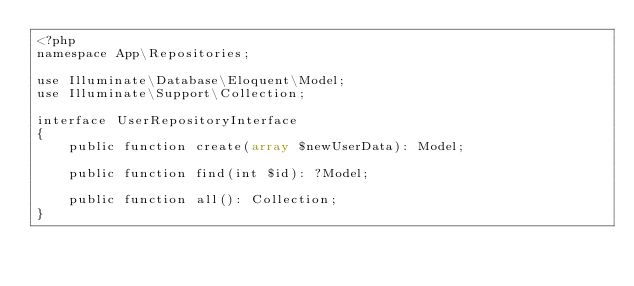<code> <loc_0><loc_0><loc_500><loc_500><_PHP_><?php
namespace App\Repositories;

use Illuminate\Database\Eloquent\Model;
use Illuminate\Support\Collection;

interface UserRepositoryInterface
{
    public function create(array $newUserData): Model;

    public function find(int $id): ?Model;

    public function all(): Collection;
}
</code> 